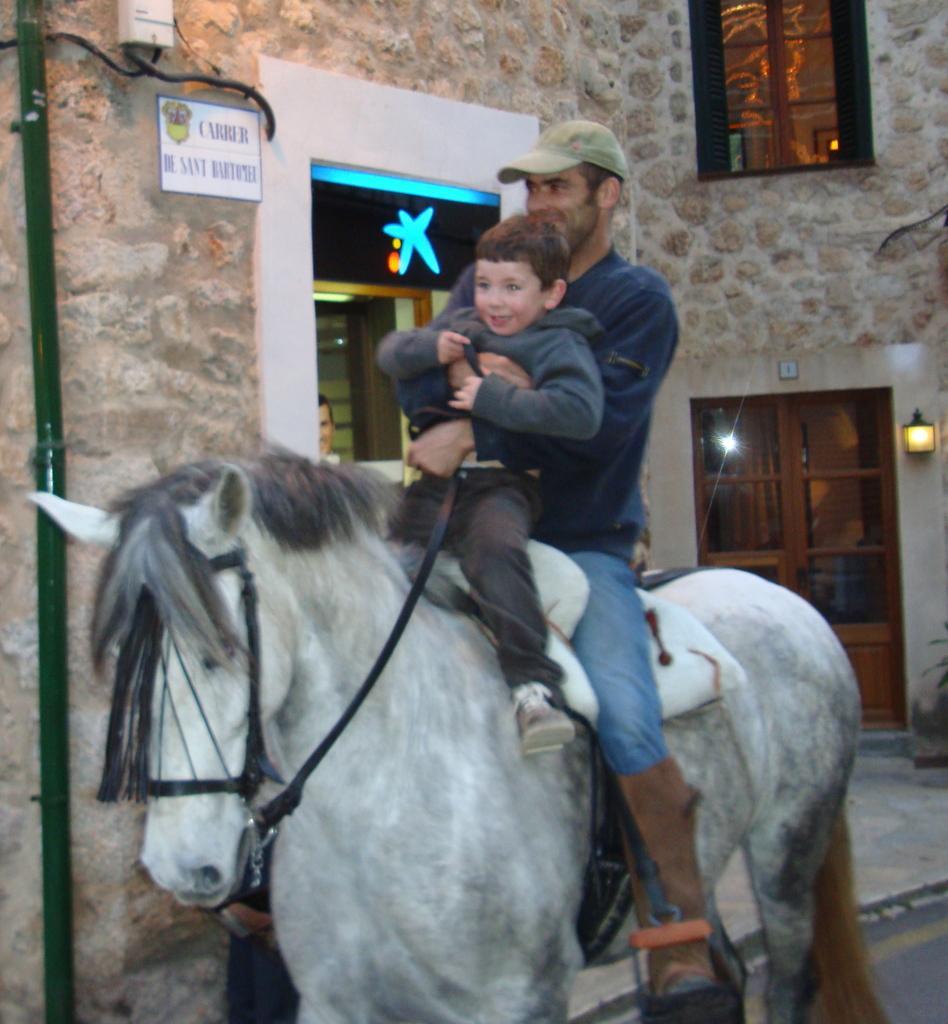Describe this image in one or two sentences. This picture shows a man and a boy riding horse and we see a house. 